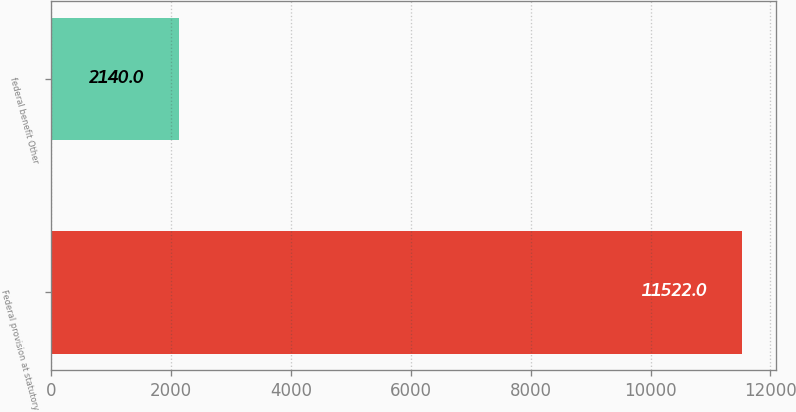<chart> <loc_0><loc_0><loc_500><loc_500><bar_chart><fcel>Federal provision at statutory<fcel>federal benefit Other<nl><fcel>11522<fcel>2140<nl></chart> 